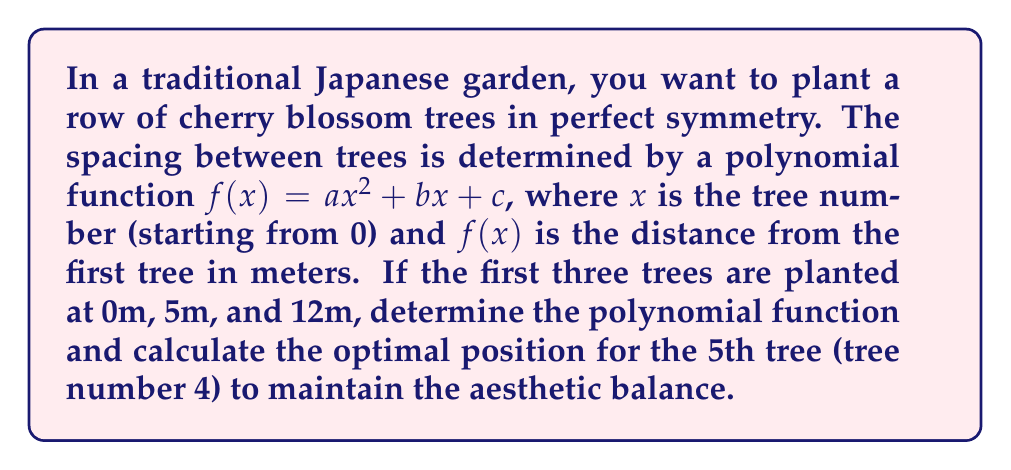Solve this math problem. Let's solve this step-by-step:

1) We have three known points:
   $(0, 0)$, $(1, 5)$, and $(2, 12)$

2) Substitute these into the general form $f(x) = ax^2 + bx + c$:
   $0 = a(0)^2 + b(0) + c$
   $5 = a(1)^2 + b(1) + c$
   $12 = a(2)^2 + b(2) + c$

3) From the first equation:
   $c = 0$

4) Now we have two equations:
   $5 = a + b$
   $12 = 4a + 2b$

5) Multiply the first equation by 2:
   $10 = 2a + 2b$

6) Subtract this from the second equation:
   $2 = 2a$
   $a = 1$

7) Substitute back to find $b$:
   $5 = 1 + b$
   $b = 4$

8) Therefore, our polynomial is:
   $f(x) = x^2 + 4x$

9) To find the position of the 5th tree (tree number 4):
   $f(4) = 4^2 + 4(4) = 16 + 16 = 32$

Thus, the 5th tree should be planted 32 meters from the first tree.
Answer: $f(x) = x^2 + 4x$; 32 meters 